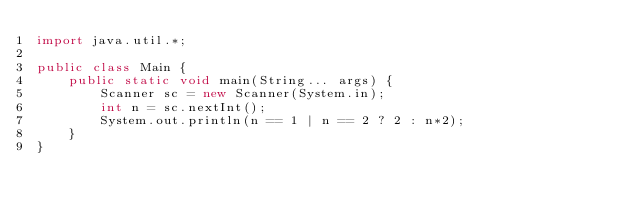Convert code to text. <code><loc_0><loc_0><loc_500><loc_500><_Java_>import java.util.*;

public class Main {
    public static void main(String... args) {
        Scanner sc = new Scanner(System.in);
        int n = sc.nextInt();
        System.out.println(n == 1 | n == 2 ? 2 : n*2);
    }
}
</code> 